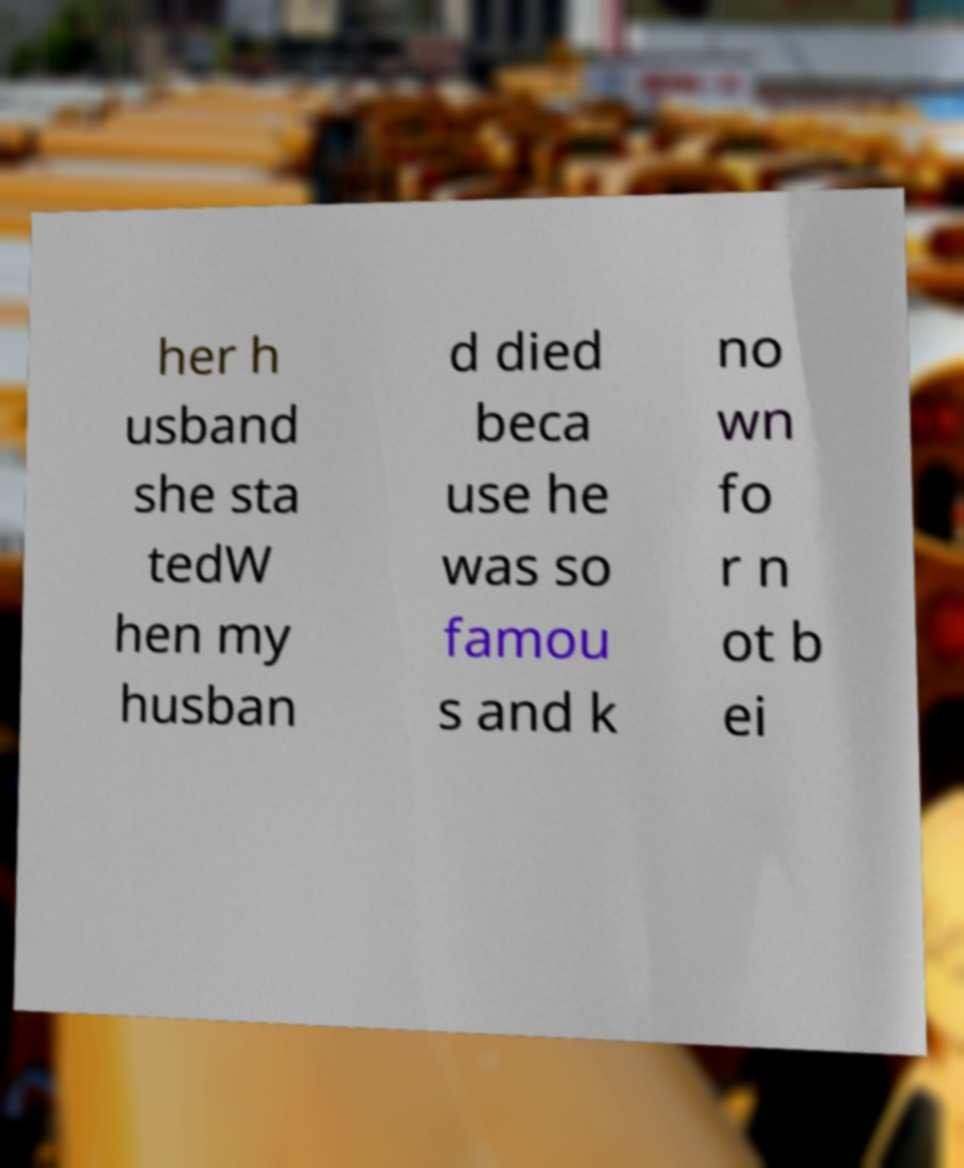Please read and relay the text visible in this image. What does it say? her h usband she sta tedW hen my husban d died beca use he was so famou s and k no wn fo r n ot b ei 